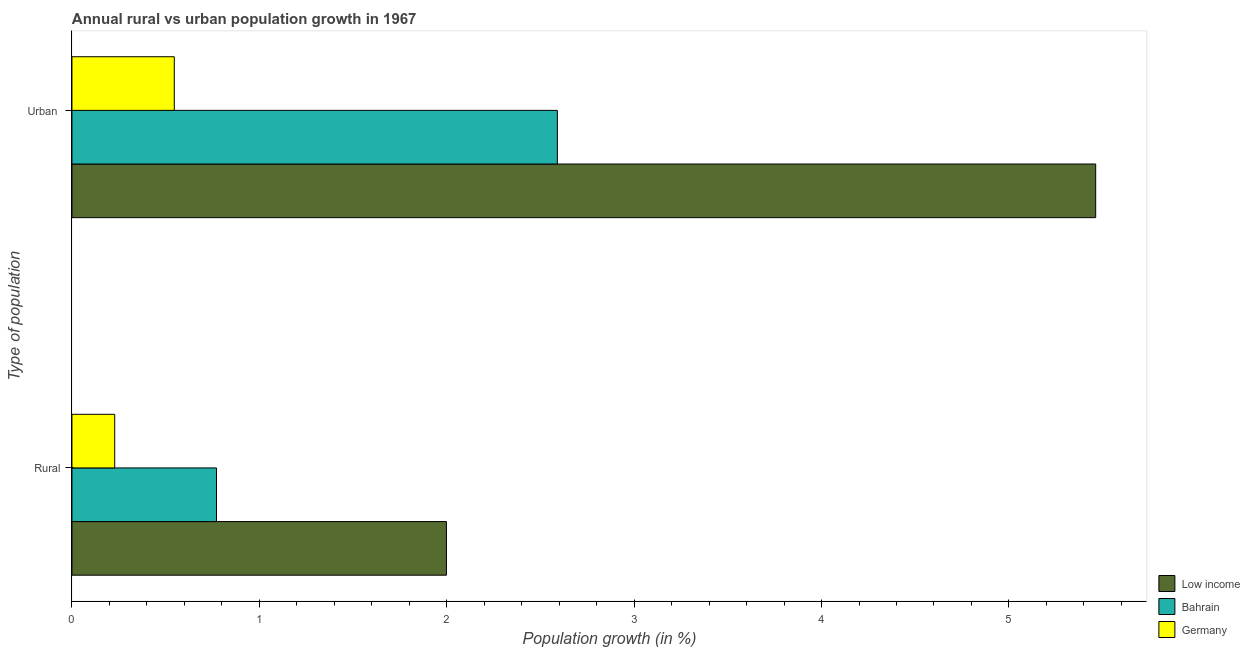How many different coloured bars are there?
Your answer should be compact. 3. How many groups of bars are there?
Offer a terse response. 2. Are the number of bars per tick equal to the number of legend labels?
Your answer should be compact. Yes. How many bars are there on the 1st tick from the bottom?
Provide a succinct answer. 3. What is the label of the 1st group of bars from the top?
Make the answer very short. Urban . What is the urban population growth in Low income?
Ensure brevity in your answer.  5.46. Across all countries, what is the maximum rural population growth?
Offer a terse response. 2. Across all countries, what is the minimum urban population growth?
Your response must be concise. 0.55. What is the total rural population growth in the graph?
Your answer should be very brief. 3. What is the difference between the urban population growth in Germany and that in Bahrain?
Make the answer very short. -2.04. What is the difference between the rural population growth in Low income and the urban population growth in Bahrain?
Offer a very short reply. -0.59. What is the average rural population growth per country?
Provide a succinct answer. 1. What is the difference between the rural population growth and urban population growth in Germany?
Ensure brevity in your answer.  -0.32. What is the ratio of the urban population growth in Low income to that in Germany?
Your answer should be compact. 10. In how many countries, is the urban population growth greater than the average urban population growth taken over all countries?
Make the answer very short. 1. What does the 2nd bar from the top in Urban  represents?
Your response must be concise. Bahrain. What does the 3rd bar from the bottom in Urban  represents?
Your response must be concise. Germany. How many bars are there?
Ensure brevity in your answer.  6. Are the values on the major ticks of X-axis written in scientific E-notation?
Your answer should be very brief. No. Does the graph contain any zero values?
Make the answer very short. No. Does the graph contain grids?
Your response must be concise. No. How many legend labels are there?
Your response must be concise. 3. How are the legend labels stacked?
Your answer should be compact. Vertical. What is the title of the graph?
Offer a very short reply. Annual rural vs urban population growth in 1967. Does "Samoa" appear as one of the legend labels in the graph?
Your response must be concise. No. What is the label or title of the X-axis?
Keep it short and to the point. Population growth (in %). What is the label or title of the Y-axis?
Your response must be concise. Type of population. What is the Population growth (in %) in Low income in Rural?
Provide a succinct answer. 2. What is the Population growth (in %) in Bahrain in Rural?
Your response must be concise. 0.77. What is the Population growth (in %) of Germany in Rural?
Ensure brevity in your answer.  0.23. What is the Population growth (in %) of Low income in Urban ?
Your answer should be compact. 5.46. What is the Population growth (in %) in Bahrain in Urban ?
Make the answer very short. 2.59. What is the Population growth (in %) in Germany in Urban ?
Offer a terse response. 0.55. Across all Type of population, what is the maximum Population growth (in %) of Low income?
Offer a very short reply. 5.46. Across all Type of population, what is the maximum Population growth (in %) of Bahrain?
Your response must be concise. 2.59. Across all Type of population, what is the maximum Population growth (in %) in Germany?
Your response must be concise. 0.55. Across all Type of population, what is the minimum Population growth (in %) of Low income?
Offer a very short reply. 2. Across all Type of population, what is the minimum Population growth (in %) in Bahrain?
Offer a very short reply. 0.77. Across all Type of population, what is the minimum Population growth (in %) of Germany?
Your response must be concise. 0.23. What is the total Population growth (in %) in Low income in the graph?
Your response must be concise. 7.46. What is the total Population growth (in %) of Bahrain in the graph?
Keep it short and to the point. 3.36. What is the total Population growth (in %) in Germany in the graph?
Make the answer very short. 0.77. What is the difference between the Population growth (in %) of Low income in Rural and that in Urban ?
Make the answer very short. -3.46. What is the difference between the Population growth (in %) of Bahrain in Rural and that in Urban ?
Your response must be concise. -1.82. What is the difference between the Population growth (in %) in Germany in Rural and that in Urban ?
Provide a short and direct response. -0.32. What is the difference between the Population growth (in %) of Low income in Rural and the Population growth (in %) of Bahrain in Urban ?
Ensure brevity in your answer.  -0.59. What is the difference between the Population growth (in %) of Low income in Rural and the Population growth (in %) of Germany in Urban ?
Your answer should be very brief. 1.45. What is the difference between the Population growth (in %) of Bahrain in Rural and the Population growth (in %) of Germany in Urban ?
Offer a very short reply. 0.23. What is the average Population growth (in %) in Low income per Type of population?
Ensure brevity in your answer.  3.73. What is the average Population growth (in %) of Bahrain per Type of population?
Your response must be concise. 1.68. What is the average Population growth (in %) of Germany per Type of population?
Your answer should be compact. 0.39. What is the difference between the Population growth (in %) in Low income and Population growth (in %) in Bahrain in Rural?
Your answer should be very brief. 1.23. What is the difference between the Population growth (in %) in Low income and Population growth (in %) in Germany in Rural?
Your answer should be very brief. 1.77. What is the difference between the Population growth (in %) of Bahrain and Population growth (in %) of Germany in Rural?
Offer a terse response. 0.54. What is the difference between the Population growth (in %) in Low income and Population growth (in %) in Bahrain in Urban ?
Your answer should be compact. 2.87. What is the difference between the Population growth (in %) in Low income and Population growth (in %) in Germany in Urban ?
Offer a terse response. 4.92. What is the difference between the Population growth (in %) of Bahrain and Population growth (in %) of Germany in Urban ?
Provide a succinct answer. 2.04. What is the ratio of the Population growth (in %) in Low income in Rural to that in Urban ?
Offer a very short reply. 0.37. What is the ratio of the Population growth (in %) in Bahrain in Rural to that in Urban ?
Provide a short and direct response. 0.3. What is the ratio of the Population growth (in %) of Germany in Rural to that in Urban ?
Your response must be concise. 0.42. What is the difference between the highest and the second highest Population growth (in %) in Low income?
Keep it short and to the point. 3.46. What is the difference between the highest and the second highest Population growth (in %) in Bahrain?
Give a very brief answer. 1.82. What is the difference between the highest and the second highest Population growth (in %) of Germany?
Make the answer very short. 0.32. What is the difference between the highest and the lowest Population growth (in %) in Low income?
Ensure brevity in your answer.  3.46. What is the difference between the highest and the lowest Population growth (in %) of Bahrain?
Ensure brevity in your answer.  1.82. What is the difference between the highest and the lowest Population growth (in %) of Germany?
Give a very brief answer. 0.32. 